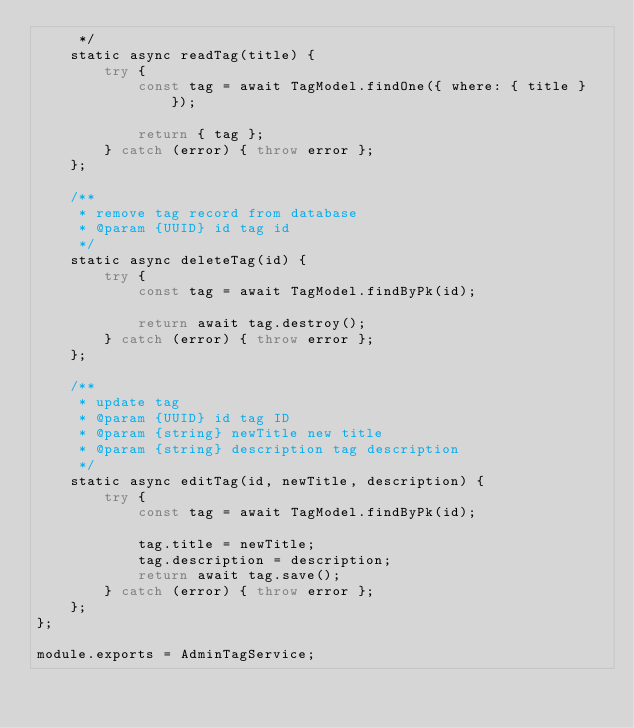<code> <loc_0><loc_0><loc_500><loc_500><_JavaScript_>     */
    static async readTag(title) {
        try {
            const tag = await TagModel.findOne({ where: { title } });

            return { tag };
        } catch (error) { throw error };
    };

    /**
     * remove tag record from database
     * @param {UUID} id tag id
     */
    static async deleteTag(id) {
        try {
            const tag = await TagModel.findByPk(id);

            return await tag.destroy();
        } catch (error) { throw error };
    };

    /**
     * update tag
     * @param {UUID} id tag ID
     * @param {string} newTitle new title
     * @param {string} description tag description
     */
    static async editTag(id, newTitle, description) {
        try {
            const tag = await TagModel.findByPk(id);

            tag.title = newTitle;
            tag.description = description;
            return await tag.save();
        } catch (error) { throw error };
    };
};

module.exports = AdminTagService;</code> 